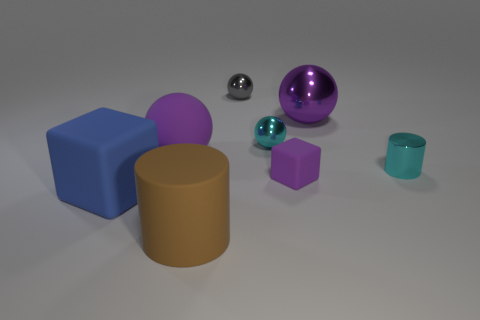Add 1 gray shiny things. How many objects exist? 9 Subtract all cylinders. How many objects are left? 6 Subtract all small cyan cylinders. Subtract all shiny spheres. How many objects are left? 4 Add 8 large metal balls. How many large metal balls are left? 9 Add 3 large rubber cylinders. How many large rubber cylinders exist? 4 Subtract 0 gray cylinders. How many objects are left? 8 